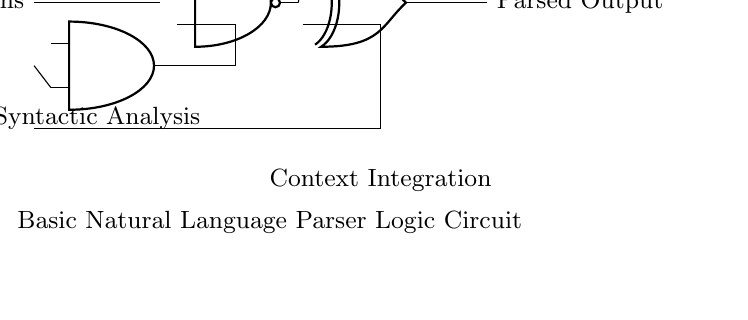What are the types of logic gates used in this circuit? The circuit includes an AND gate, an OR gate, a NAND gate, and an XOR gate. Each gate plays a specific role in processing input tokens.
Answer: AND, OR, NAND, XOR What is the function of the AND gate in this circuit? The AND gate takes inputs from the input tokens and is responsible for syntactic analysis, meaning it checks if both conditions (or tokens) are true to generate an output.
Answer: Syntactic analysis What role does the OR gate serve in the circuit? The OR gate processes the input tokens, allowing the circuit to pass an output if at least one of the inputs is true, contributing to lexical analysis.
Answer: Lexical analysis Which part of the circuit performs semantic analysis? The NAND gate's output is connected to the XOR gate, allowing the proper interpretation of semantic meaning from combined inputs. This indicates its role in interpreting the overall meaning.
Answer: NAND gate How many input tokens are there in the circuit? There are two input tokens shown entering the circuit, which are processed by the various gates for analysis.
Answer: Two What outputs are generated from the circuit? The final output from the circuit is labeled as "Parsed Output," indicating the end result after processing the input tokens through the gates.
Answer: Parsed Output 